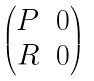Convert formula to latex. <formula><loc_0><loc_0><loc_500><loc_500>\begin{pmatrix} P & 0 \\ R & 0 \end{pmatrix}</formula> 